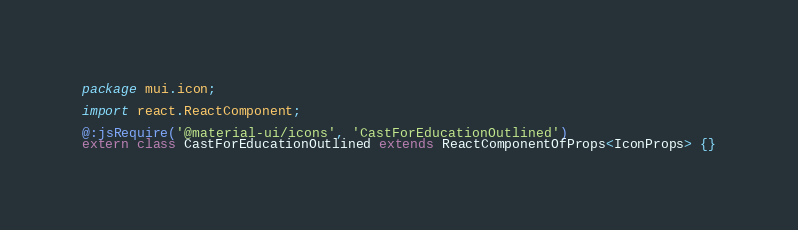Convert code to text. <code><loc_0><loc_0><loc_500><loc_500><_Haxe_>package mui.icon;

import react.ReactComponent;

@:jsRequire('@material-ui/icons', 'CastForEducationOutlined')
extern class CastForEducationOutlined extends ReactComponentOfProps<IconProps> {}
</code> 